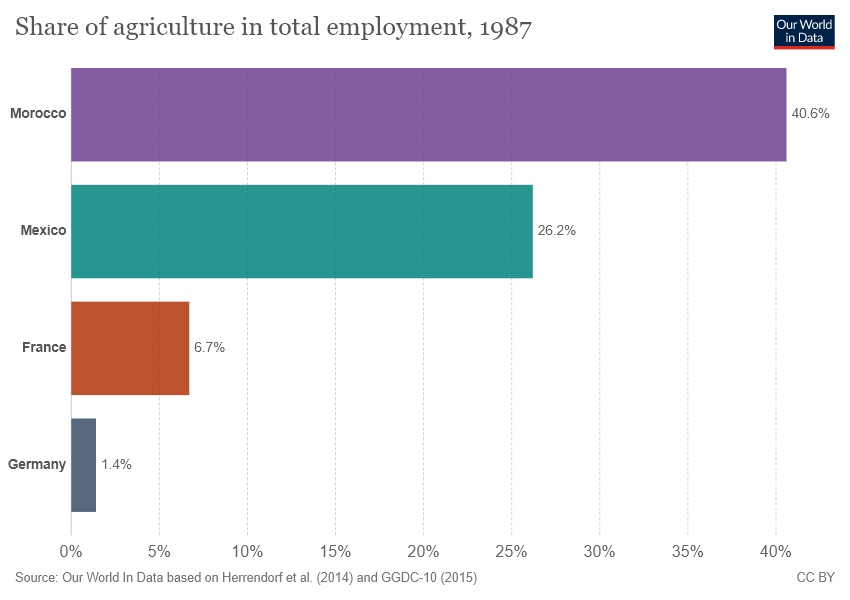Mention a couple of crucial points in this snapshot. To find the average of two highest values and the sum of two lowest values, one must first calculate each value separately. The highest value is the maximum of the two numbers, while the lowest value is the minimum. Once these values have been determined, the average can be calculated by adding the highest and lowest values and dividing by the number of values. The final answer should be presented in the format A:B, where A represents the average and B represents the sum of the lowest values. An example of this calculation would be 4.1234567901234565... 